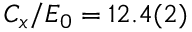<formula> <loc_0><loc_0><loc_500><loc_500>C _ { x } / E _ { 0 } = 1 2 . 4 ( 2 )</formula> 